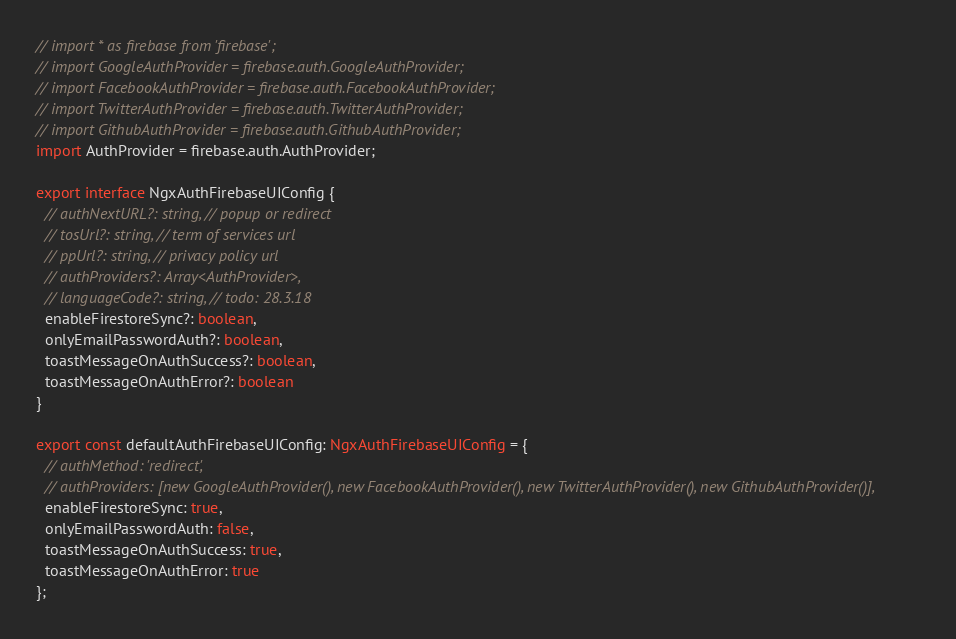Convert code to text. <code><loc_0><loc_0><loc_500><loc_500><_TypeScript_>// import * as firebase from 'firebase';
// import GoogleAuthProvider = firebase.auth.GoogleAuthProvider;
// import FacebookAuthProvider = firebase.auth.FacebookAuthProvider;
// import TwitterAuthProvider = firebase.auth.TwitterAuthProvider;
// import GithubAuthProvider = firebase.auth.GithubAuthProvider;
import AuthProvider = firebase.auth.AuthProvider;

export interface NgxAuthFirebaseUIConfig {
  // authNextURL?: string, // popup or redirect
  // tosUrl?: string, // term of services url
  // ppUrl?: string, // privacy policy url
  // authProviders?: Array<AuthProvider>,
  // languageCode?: string, // todo: 28.3.18
  enableFirestoreSync?: boolean,
  onlyEmailPasswordAuth?: boolean,
  toastMessageOnAuthSuccess?: boolean,
  toastMessageOnAuthError?: boolean
}

export const defaultAuthFirebaseUIConfig: NgxAuthFirebaseUIConfig = {
  // authMethod: 'redirect',
  // authProviders: [new GoogleAuthProvider(), new FacebookAuthProvider(), new TwitterAuthProvider(), new GithubAuthProvider()],
  enableFirestoreSync: true,
  onlyEmailPasswordAuth: false,
  toastMessageOnAuthSuccess: true,
  toastMessageOnAuthError: true
};

</code> 